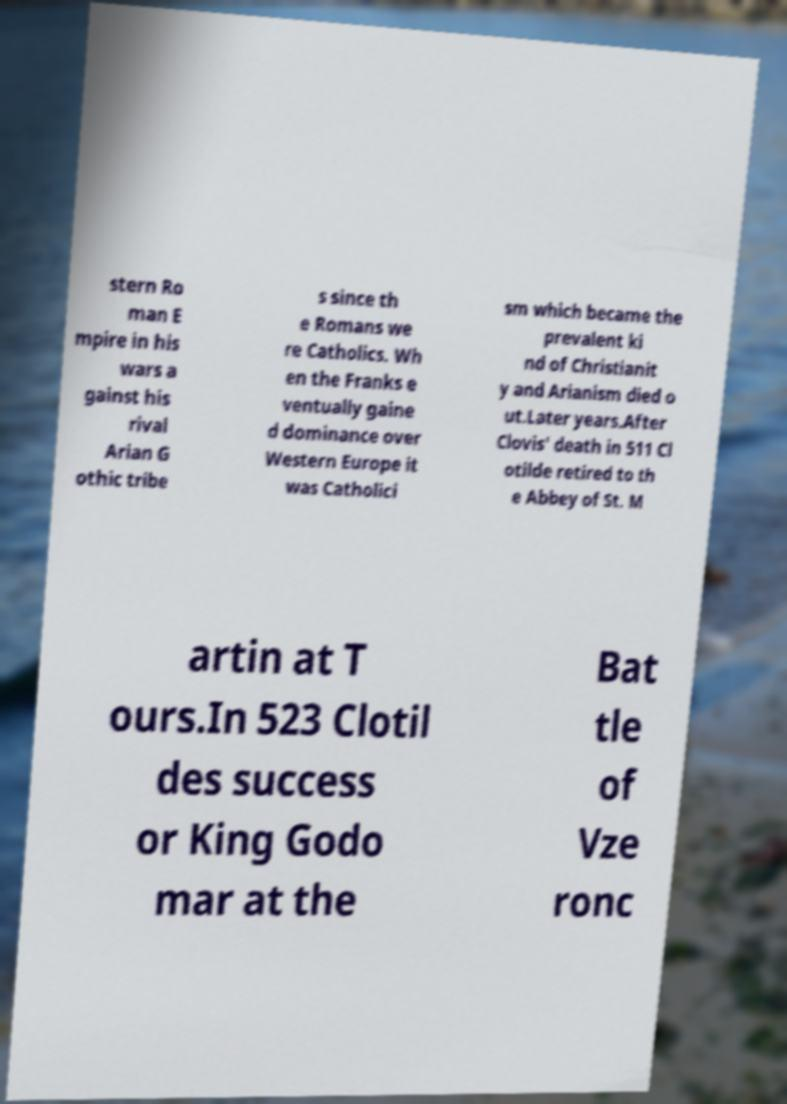Could you assist in decoding the text presented in this image and type it out clearly? stern Ro man E mpire in his wars a gainst his rival Arian G othic tribe s since th e Romans we re Catholics. Wh en the Franks e ventually gaine d dominance over Western Europe it was Catholici sm which became the prevalent ki nd of Christianit y and Arianism died o ut.Later years.After Clovis' death in 511 Cl otilde retired to th e Abbey of St. M artin at T ours.In 523 Clotil des success or King Godo mar at the Bat tle of Vze ronc 